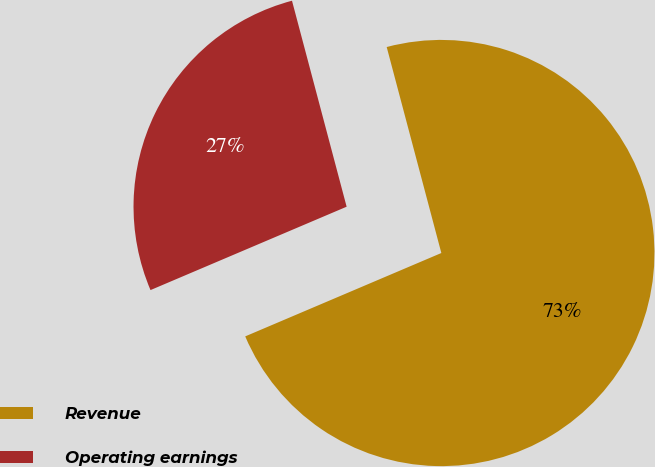Convert chart. <chart><loc_0><loc_0><loc_500><loc_500><pie_chart><fcel>Revenue<fcel>Operating earnings<nl><fcel>72.73%<fcel>27.27%<nl></chart> 